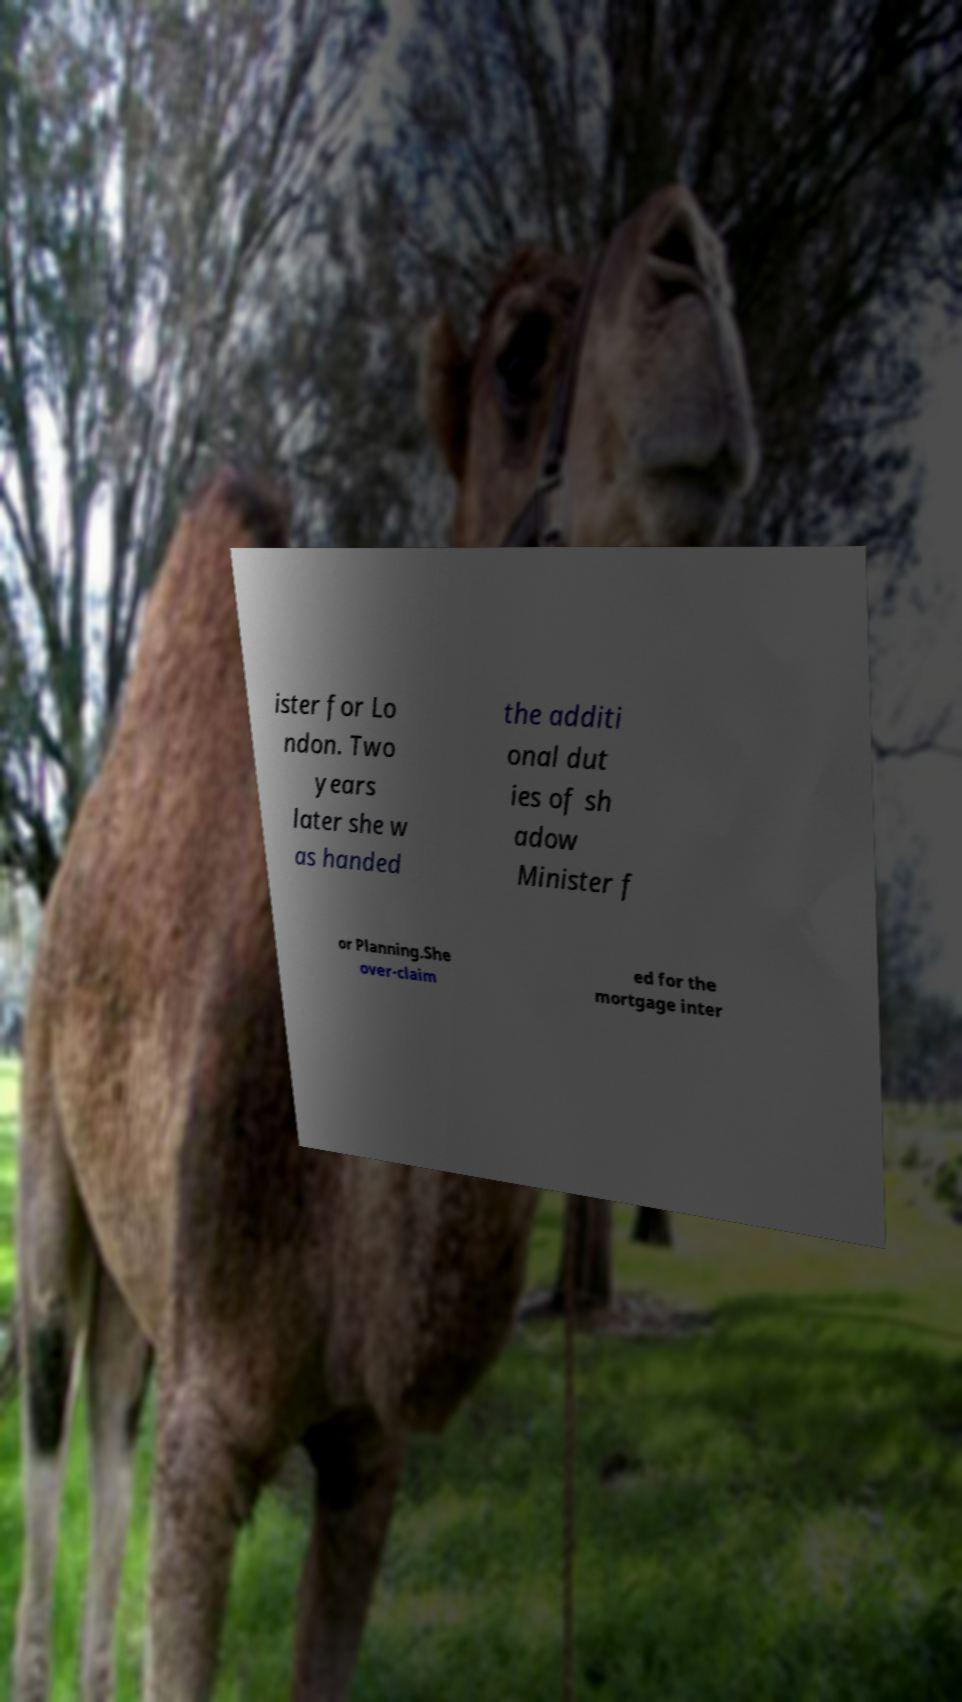Could you extract and type out the text from this image? ister for Lo ndon. Two years later she w as handed the additi onal dut ies of sh adow Minister f or Planning.She over-claim ed for the mortgage inter 